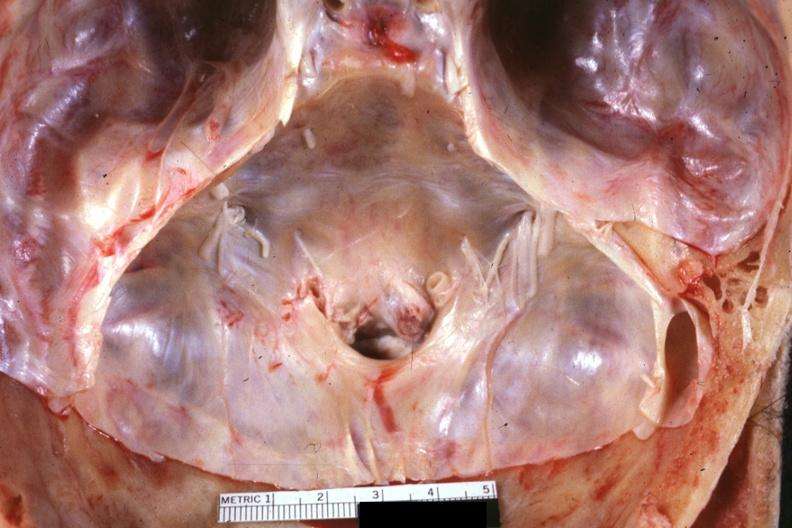s bone , calvarium present?
Answer the question using a single word or phrase. Yes 